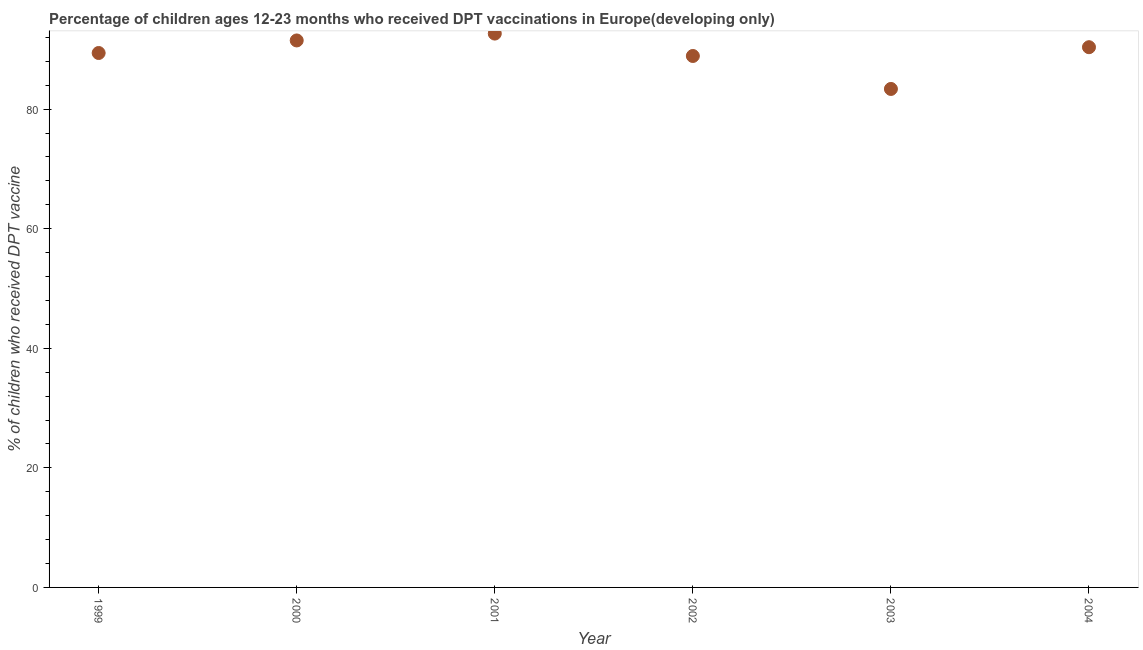What is the percentage of children who received dpt vaccine in 1999?
Provide a short and direct response. 89.38. Across all years, what is the maximum percentage of children who received dpt vaccine?
Keep it short and to the point. 92.63. Across all years, what is the minimum percentage of children who received dpt vaccine?
Offer a very short reply. 83.37. In which year was the percentage of children who received dpt vaccine maximum?
Make the answer very short. 2001. What is the sum of the percentage of children who received dpt vaccine?
Make the answer very short. 536.11. What is the difference between the percentage of children who received dpt vaccine in 2000 and 2001?
Your answer should be compact. -1.15. What is the average percentage of children who received dpt vaccine per year?
Provide a short and direct response. 89.35. What is the median percentage of children who received dpt vaccine?
Make the answer very short. 89.87. In how many years, is the percentage of children who received dpt vaccine greater than 84 %?
Ensure brevity in your answer.  5. Do a majority of the years between 2000 and 2002 (inclusive) have percentage of children who received dpt vaccine greater than 68 %?
Provide a succinct answer. Yes. What is the ratio of the percentage of children who received dpt vaccine in 1999 to that in 2002?
Make the answer very short. 1.01. Is the percentage of children who received dpt vaccine in 2001 less than that in 2002?
Provide a succinct answer. No. What is the difference between the highest and the second highest percentage of children who received dpt vaccine?
Keep it short and to the point. 1.15. Is the sum of the percentage of children who received dpt vaccine in 2000 and 2002 greater than the maximum percentage of children who received dpt vaccine across all years?
Your answer should be very brief. Yes. What is the difference between the highest and the lowest percentage of children who received dpt vaccine?
Keep it short and to the point. 9.26. How many dotlines are there?
Your answer should be compact. 1. Does the graph contain any zero values?
Ensure brevity in your answer.  No. Does the graph contain grids?
Your response must be concise. No. What is the title of the graph?
Keep it short and to the point. Percentage of children ages 12-23 months who received DPT vaccinations in Europe(developing only). What is the label or title of the X-axis?
Provide a short and direct response. Year. What is the label or title of the Y-axis?
Offer a very short reply. % of children who received DPT vaccine. What is the % of children who received DPT vaccine in 1999?
Offer a terse response. 89.38. What is the % of children who received DPT vaccine in 2000?
Offer a very short reply. 91.48. What is the % of children who received DPT vaccine in 2001?
Keep it short and to the point. 92.63. What is the % of children who received DPT vaccine in 2002?
Provide a short and direct response. 88.89. What is the % of children who received DPT vaccine in 2003?
Make the answer very short. 83.37. What is the % of children who received DPT vaccine in 2004?
Your answer should be compact. 90.35. What is the difference between the % of children who received DPT vaccine in 1999 and 2000?
Offer a terse response. -2.1. What is the difference between the % of children who received DPT vaccine in 1999 and 2001?
Keep it short and to the point. -3.25. What is the difference between the % of children who received DPT vaccine in 1999 and 2002?
Offer a terse response. 0.5. What is the difference between the % of children who received DPT vaccine in 1999 and 2003?
Your response must be concise. 6.01. What is the difference between the % of children who received DPT vaccine in 1999 and 2004?
Provide a succinct answer. -0.97. What is the difference between the % of children who received DPT vaccine in 2000 and 2001?
Provide a succinct answer. -1.15. What is the difference between the % of children who received DPT vaccine in 2000 and 2002?
Your response must be concise. 2.6. What is the difference between the % of children who received DPT vaccine in 2000 and 2003?
Offer a terse response. 8.11. What is the difference between the % of children who received DPT vaccine in 2000 and 2004?
Provide a succinct answer. 1.13. What is the difference between the % of children who received DPT vaccine in 2001 and 2002?
Your answer should be very brief. 3.74. What is the difference between the % of children who received DPT vaccine in 2001 and 2003?
Provide a succinct answer. 9.26. What is the difference between the % of children who received DPT vaccine in 2001 and 2004?
Your answer should be very brief. 2.28. What is the difference between the % of children who received DPT vaccine in 2002 and 2003?
Provide a succinct answer. 5.51. What is the difference between the % of children who received DPT vaccine in 2002 and 2004?
Keep it short and to the point. -1.47. What is the difference between the % of children who received DPT vaccine in 2003 and 2004?
Offer a terse response. -6.98. What is the ratio of the % of children who received DPT vaccine in 1999 to that in 2002?
Offer a very short reply. 1.01. What is the ratio of the % of children who received DPT vaccine in 1999 to that in 2003?
Keep it short and to the point. 1.07. What is the ratio of the % of children who received DPT vaccine in 2000 to that in 2001?
Offer a very short reply. 0.99. What is the ratio of the % of children who received DPT vaccine in 2000 to that in 2003?
Your response must be concise. 1.1. What is the ratio of the % of children who received DPT vaccine in 2001 to that in 2002?
Provide a succinct answer. 1.04. What is the ratio of the % of children who received DPT vaccine in 2001 to that in 2003?
Provide a succinct answer. 1.11. What is the ratio of the % of children who received DPT vaccine in 2002 to that in 2003?
Ensure brevity in your answer.  1.07. What is the ratio of the % of children who received DPT vaccine in 2002 to that in 2004?
Offer a very short reply. 0.98. What is the ratio of the % of children who received DPT vaccine in 2003 to that in 2004?
Make the answer very short. 0.92. 